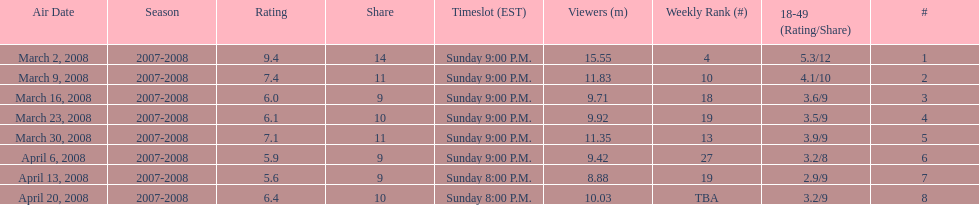Did the season finish at an earlier or later timeslot? Earlier. 